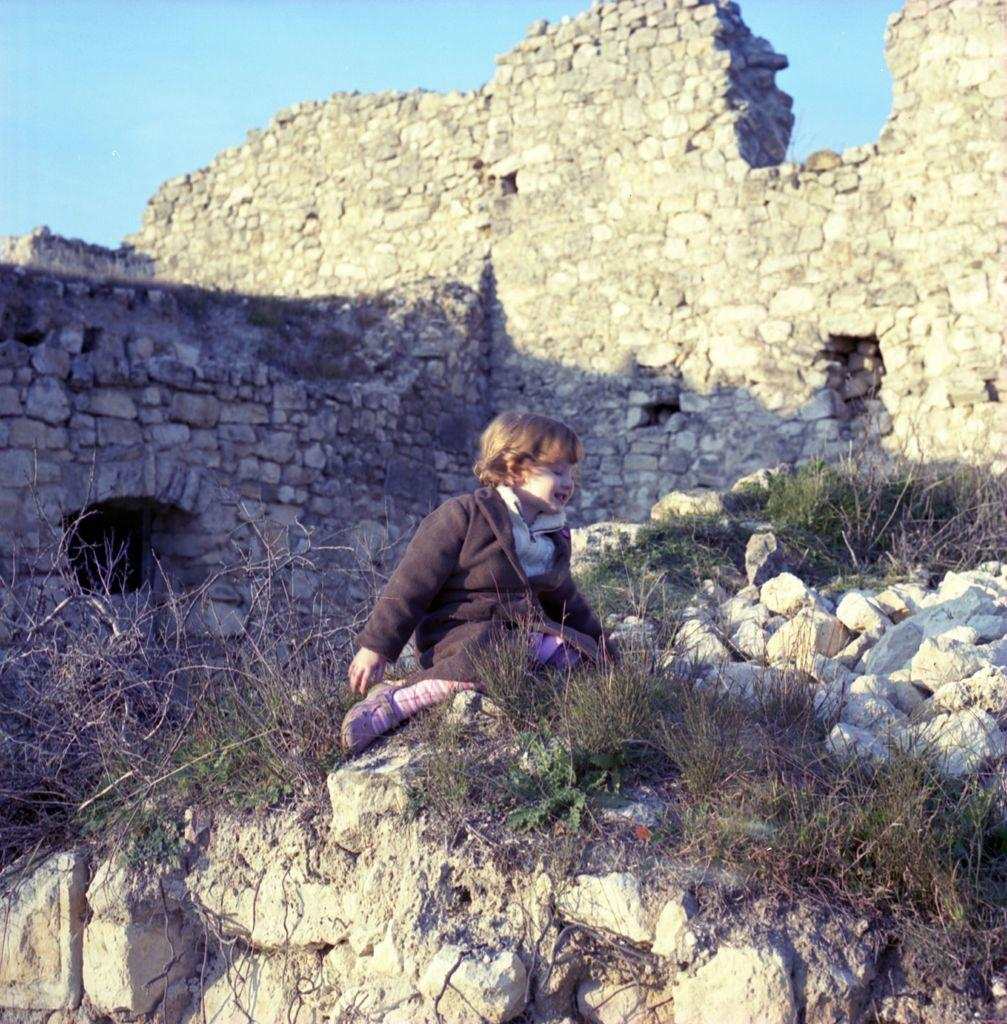What is the main subject of the image? The main subject of the image is a kid. Where is the kid sitting in the image? The kid is sitting on a rock surface. What type of vegetation can be seen in the image? There is grass and plants in the image. What can be seen in the background of the image? There is a fort-like structure in the background of the image. Can you find the receipt for the kid's purchase in the image? There is no receipt present in the image. What nerve is responsible for the kid's ability to sit on the rock surface? The image does not provide information about the kid's nerves or their ability to sit on the rock surface. 